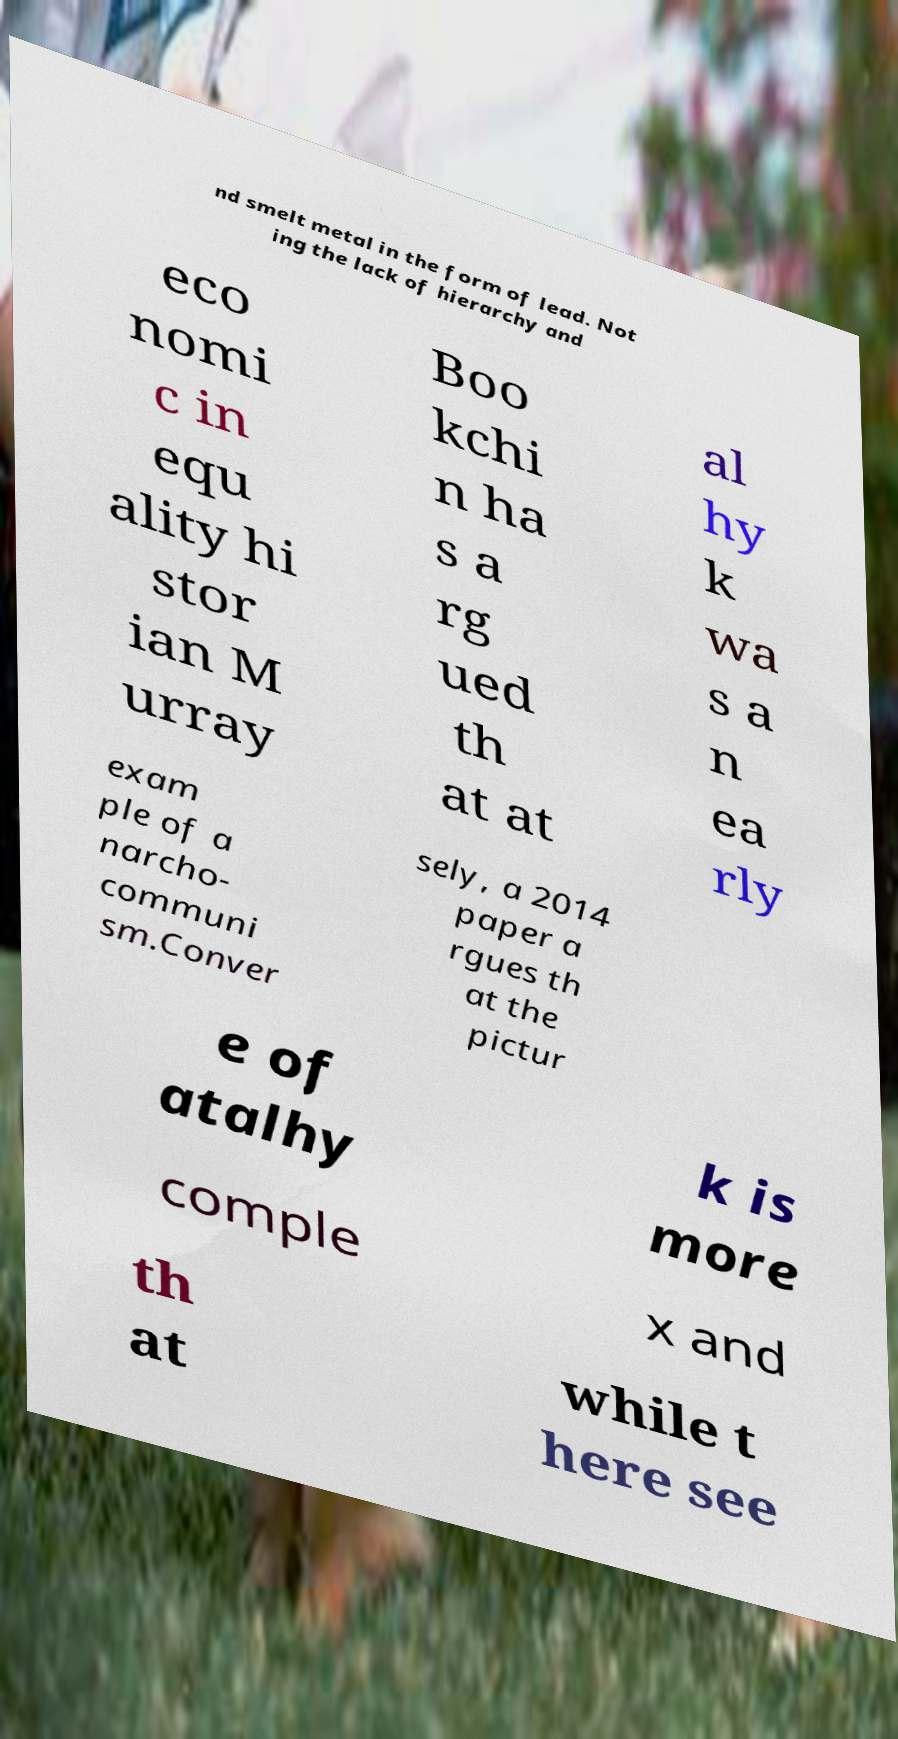There's text embedded in this image that I need extracted. Can you transcribe it verbatim? nd smelt metal in the form of lead. Not ing the lack of hierarchy and eco nomi c in equ ality hi stor ian M urray Boo kchi n ha s a rg ued th at at al hy k wa s a n ea rly exam ple of a narcho- communi sm.Conver sely, a 2014 paper a rgues th at the pictur e of atalhy k is more comple x and th at while t here see 